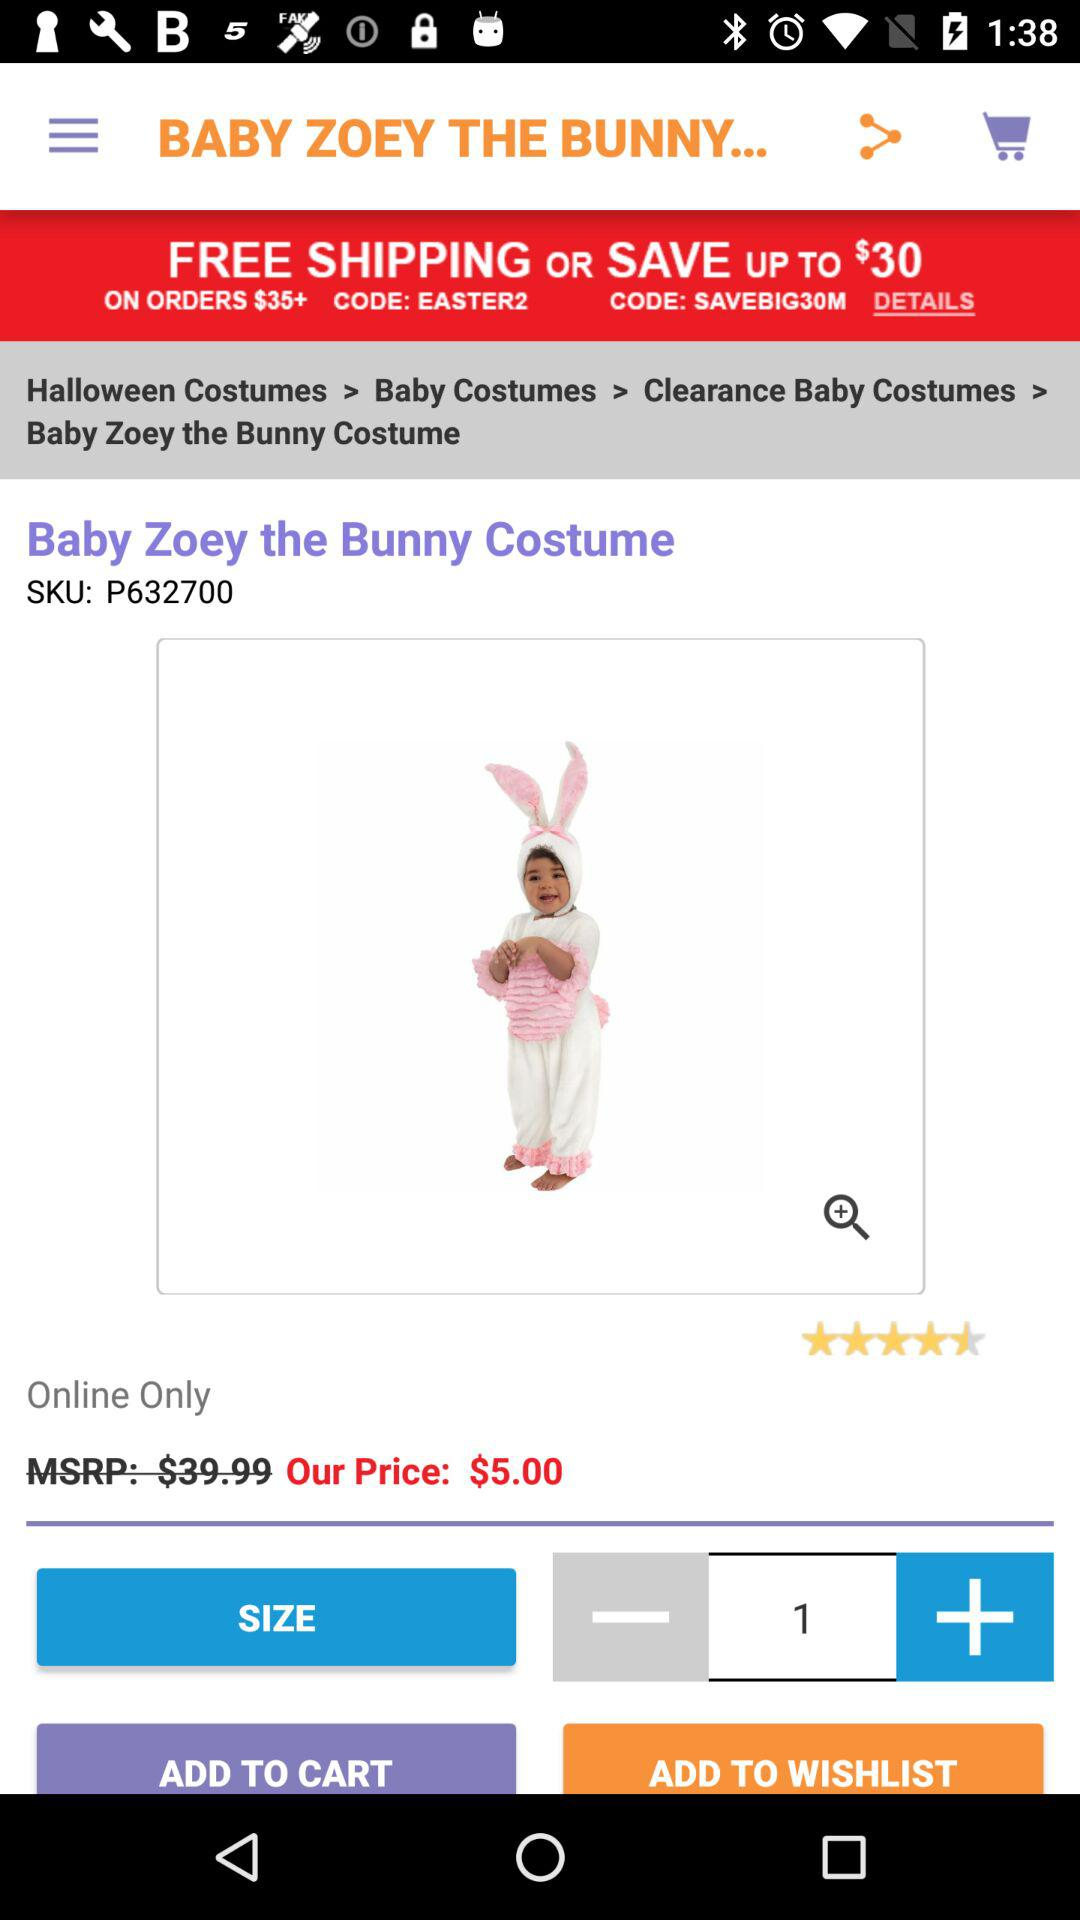How much is the original price of the product?
Answer the question using a single word or phrase. $39.99 